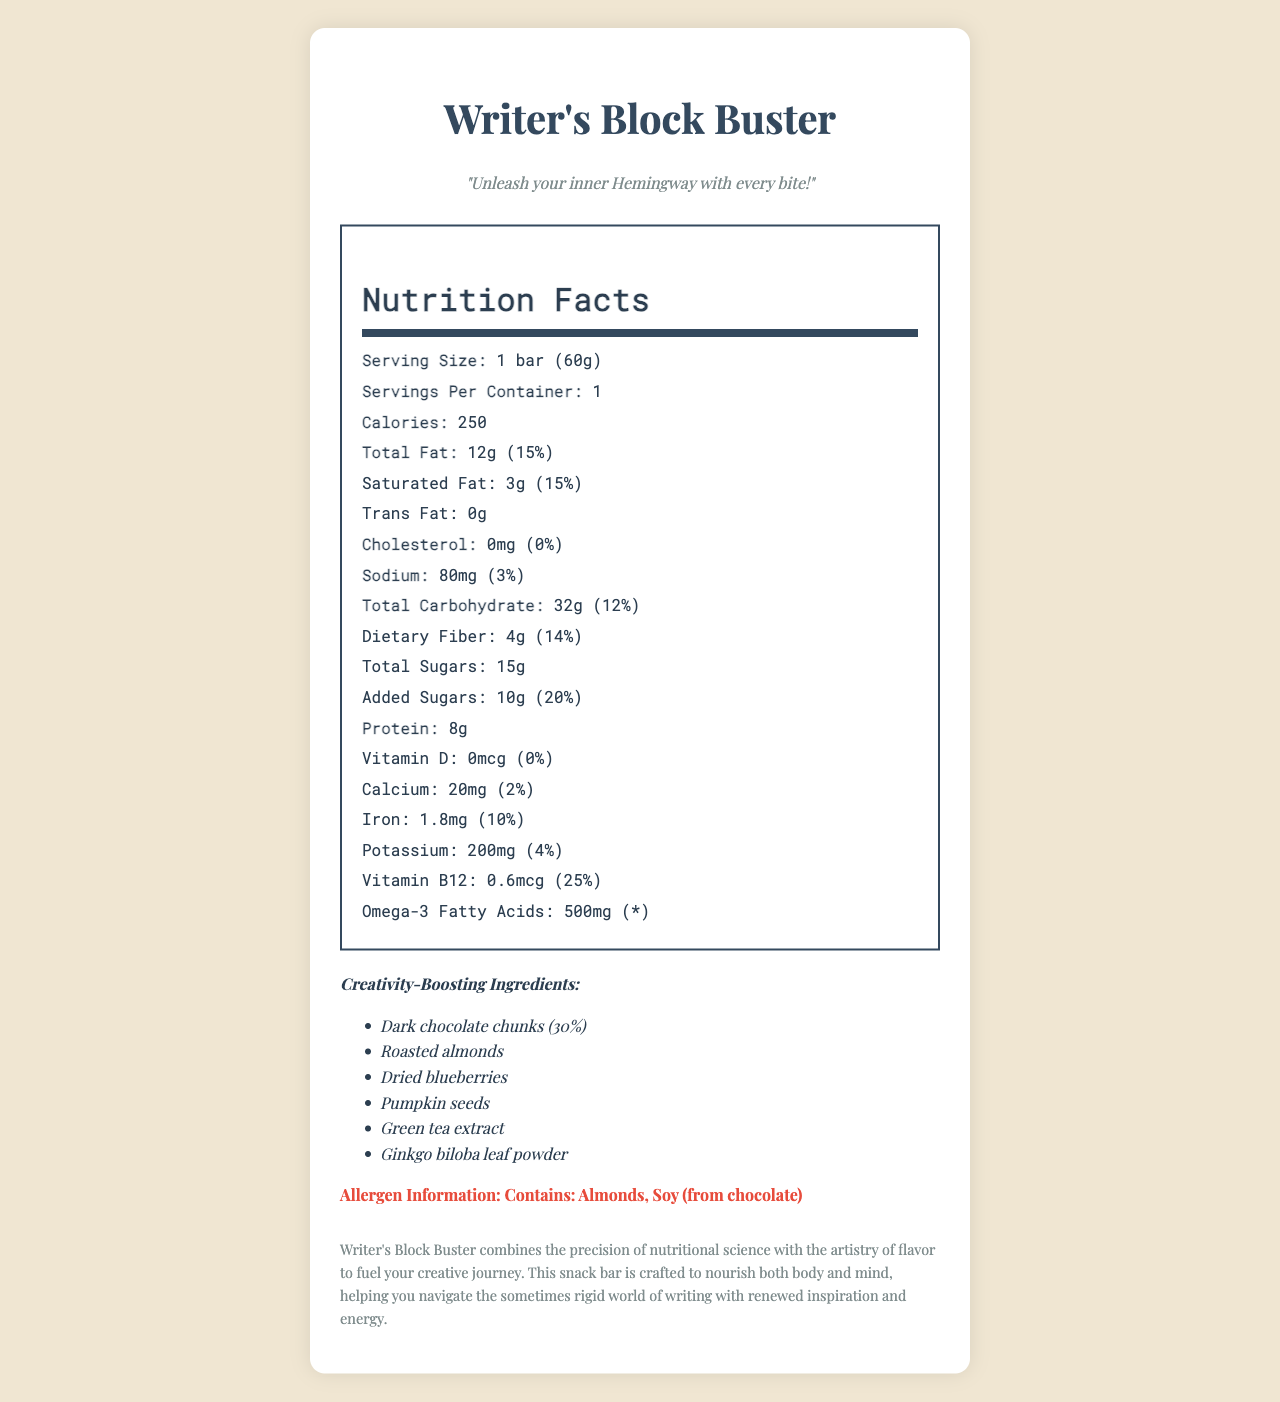what is the serving size? The serving size is explicitly listed as "1 bar (60g)" in the document.
Answer: 1 bar (60g) how much protein does the Writer's Block Buster snack bar contain? The document indicates that the protein content in the bar is 8 grams.
Answer: 8g what percentage of the daily value for Vitamin B12 does the snack bar provide? According to the document, the daily value percentage for Vitamin B12 is 25%.
Answer: 25% how many grams of total carbohydrates are in one serving? The document specifies that the total carbohydrate amount per serving is 32 grams.
Answer: 32g does the snack bar contain any cholesterol? The cholesterol amount is listed as 0mg, which shows that it contains no cholesterol.
Answer: No what allergen is present in the snack bar? The allergen information provided in the document indicates the presence of almonds and soy from chocolate.
Answer: Almonds, Soy (from chocolate) how many calories are in one serving of the snack bar? The document clearly states that there are 250 calories in one serving.
Answer: 250 calories what is the tagline of the Writer's Block Buster snack bar? A. Fuel Your Creativity B. Unleash Your Inner Hemingway C. Inspire Your Writing D. Boost Your Mind The tagline mentioned in the document is "Unleash your inner Hemingway with every bite!"
Answer: B. Unleash Your Inner Hemingway which ingredient is NOT part of the creativity-boosting ingredients? i. Dark chocolate chunks ii. Sunflower seeds iii. Dried blueberries iv. Pumpkin seeds Sunflower seeds are not listed among the creativity-boosting ingredients which include dark chocolate chunks, roasted almonds, dried blueberries, pumpkin seeds, green tea extract, and ginkgo biloba leaf powder.
Answer: ii. Sunflower seeds is the information about the bar's Omega-3 Fatty Acids daily value provided? The document lists "Omega-3 Fatty Acids: 500mg" but does not provide a daily value percentage for it, indicating "*".
Answer: No does the snack bar contain any added sugars? The document states that there are 10g of added sugars in the snack bar.
Answer: Yes what are the main points described in the product description? The product description emphasizes the combination of nutritional science with flavor artistry, aiming to nourish body and mind, and aid in navigating the writing process with renewed inspiration and energy.
Answer: Writer's Block Buster combines the precision of nutritional science with the artistry of flavor to fuel your creative journey. This snack bar is crafted to nourish both body and mind, helping you navigate the sometimes rigid world of writing with renewed inspiration and energy. what is the exact amount of Vitamin D in the snack bar? The document specifies that the Vitamin D content is 0 micrograms.
Answer: 0mcg how much calcium does the snack bar provide in percentage terms? The document mentions that the daily value percentage for calcium is 2%.
Answer: 2% how many servings per container are there? The document lists the servings per container as 1, implying that the entire container is a single serving.
Answer: 1 what is the main idea of the Writer's Block Buster snack bar document? The main idea centers on presenting the nutritional information, creativity-enhancing ingredients, and the relationship between the snack bar and the creative process, along with allergen details and a product description.
Answer: The document provides a detailed nutritional breakdown of the Writer's Block Buster snack bar, highlighting its creativity-boosting ingredients, calorie content, various nutrient amounts, and daily value percentages. It also includes allergen information and a product description that connects the snack to the creative process of writing. what is the source of the Omega-3 Fatty Acids in the snack bar? The document provides the amount of Omega-3 Fatty Acids but does not specify the source of these fatty acids.
Answer: Not enough information 